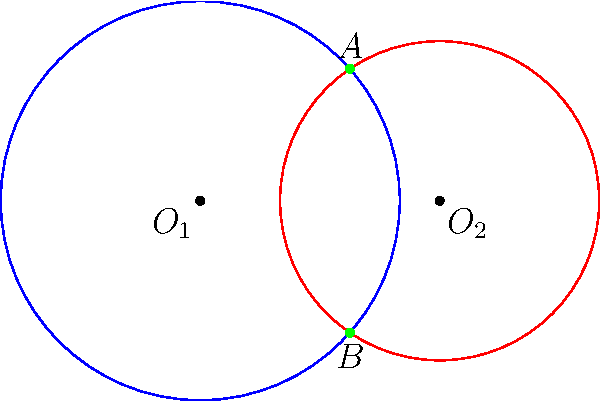Two aid distribution zones are represented by overlapping circles in a coordinate system. The first zone, centered at $(0,0)$ with a radius of 5 units, overlaps with the second zone, centered at $(6,0)$ with a radius of 4 units. Calculate the $y$-coordinates of the intersection points of these two zones to determine the extent of the overlap. To find the $y$-coordinates of the intersection points, we'll follow these steps:

1) The equations of the two circles are:
   Circle 1: $x^2 + y^2 = 25$ (radius 5, center at origin)
   Circle 2: $(x-6)^2 + y^2 = 16$ (radius 4, center at (6,0))

2) At the intersection points, both equations are satisfied. Subtracting the second equation from the first:
   $x^2 + y^2 - [(x-6)^2 + y^2] = 25 - 16$
   $x^2 - (x^2 - 12x + 36) = 9$
   $12x - 36 = 9$
   $12x = 45$
   $x = \frac{45}{12} = \frac{15}{4} = 3.75$

3) This $x$-coordinate is the same for both intersection points. We can substitute it back into either circle equation to find $y$. Let's use the first equation:
   $(\frac{15}{4})^2 + y^2 = 25$
   $\frac{225}{16} + y^2 = 25$
   $y^2 = 25 - \frac{225}{16} = \frac{400-225}{16} = \frac{175}{16}$
   $y = \pm \sqrt{\frac{175}{16}} = \pm \frac{\sqrt{175}}{4} \approx \pm 3.307$

4) Therefore, the $y$-coordinates of the intersection points are approximately 3.307 and -3.307.
Answer: $y \approx \pm 3.307$ 